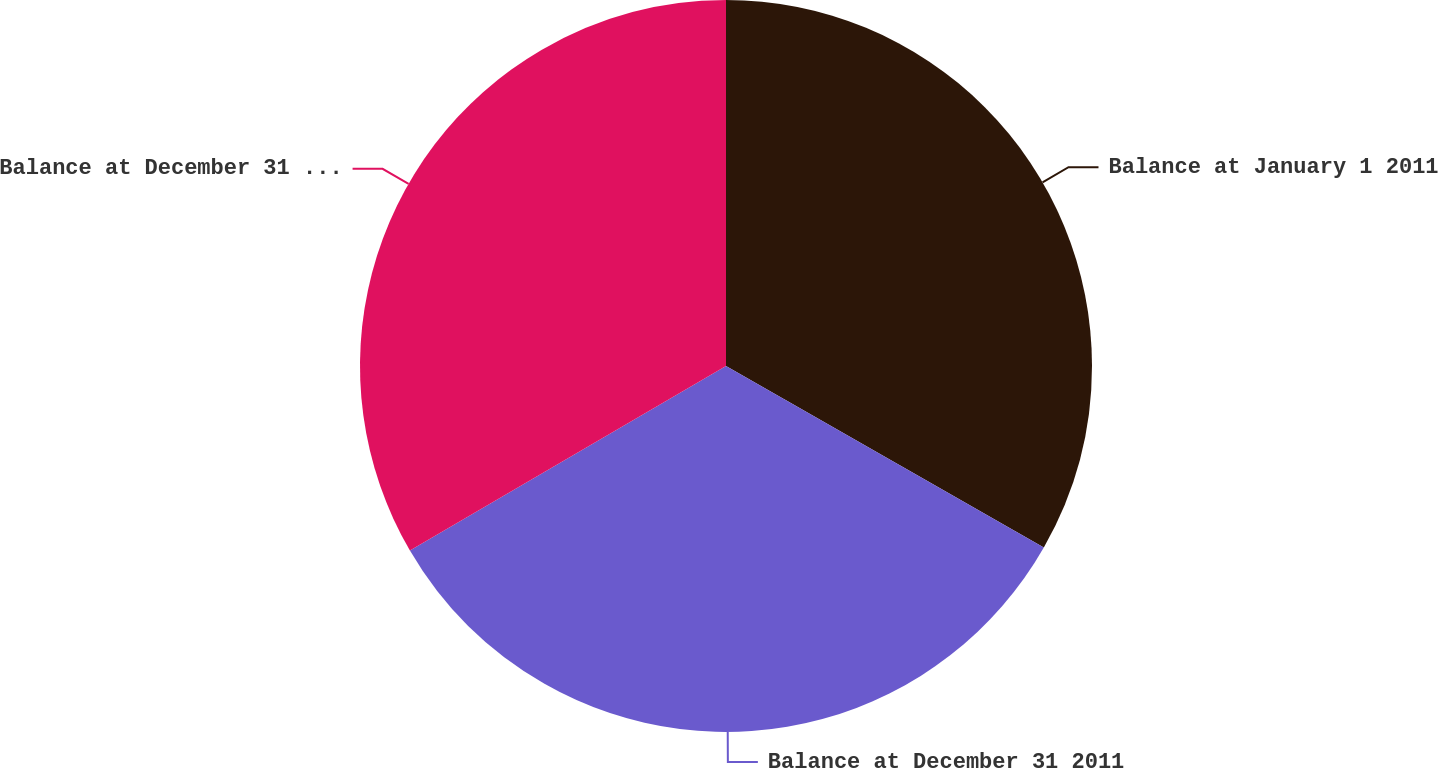<chart> <loc_0><loc_0><loc_500><loc_500><pie_chart><fcel>Balance at January 1 2011<fcel>Balance at December 31 2011<fcel>Balance at December 31 2012<nl><fcel>33.26%<fcel>33.33%<fcel>33.41%<nl></chart> 